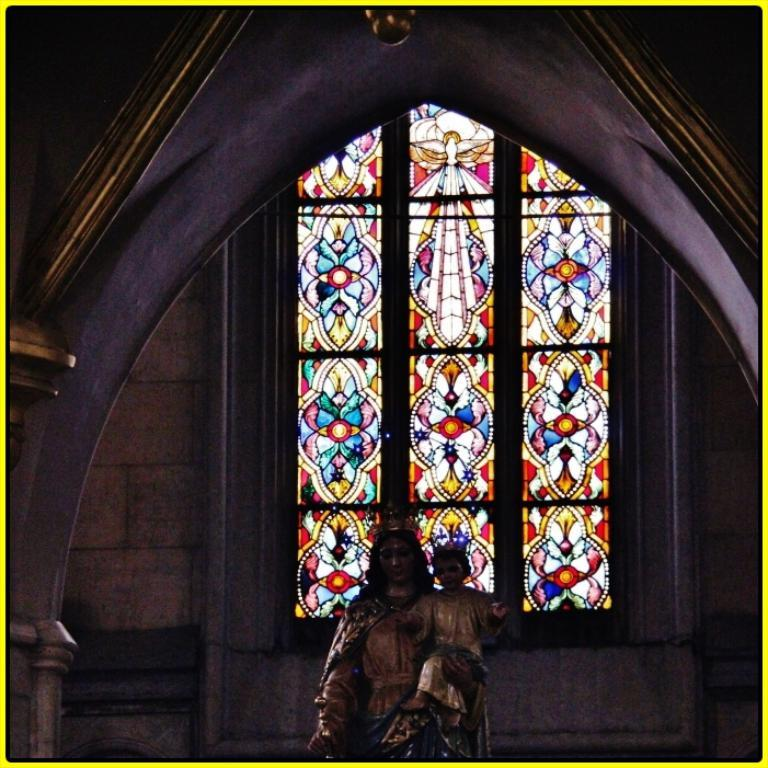What is the main subject of the image? There is a statue in the image. Where is the statue located in the image? The statue is located at the bottom of the image. What else can be seen in the image besides the statue? There is a wall visible in the image. What is a notable feature of the wall? A stained glass is present on the wall. What type of linen is draped over the statue in the image? There is no linen present in the image. 